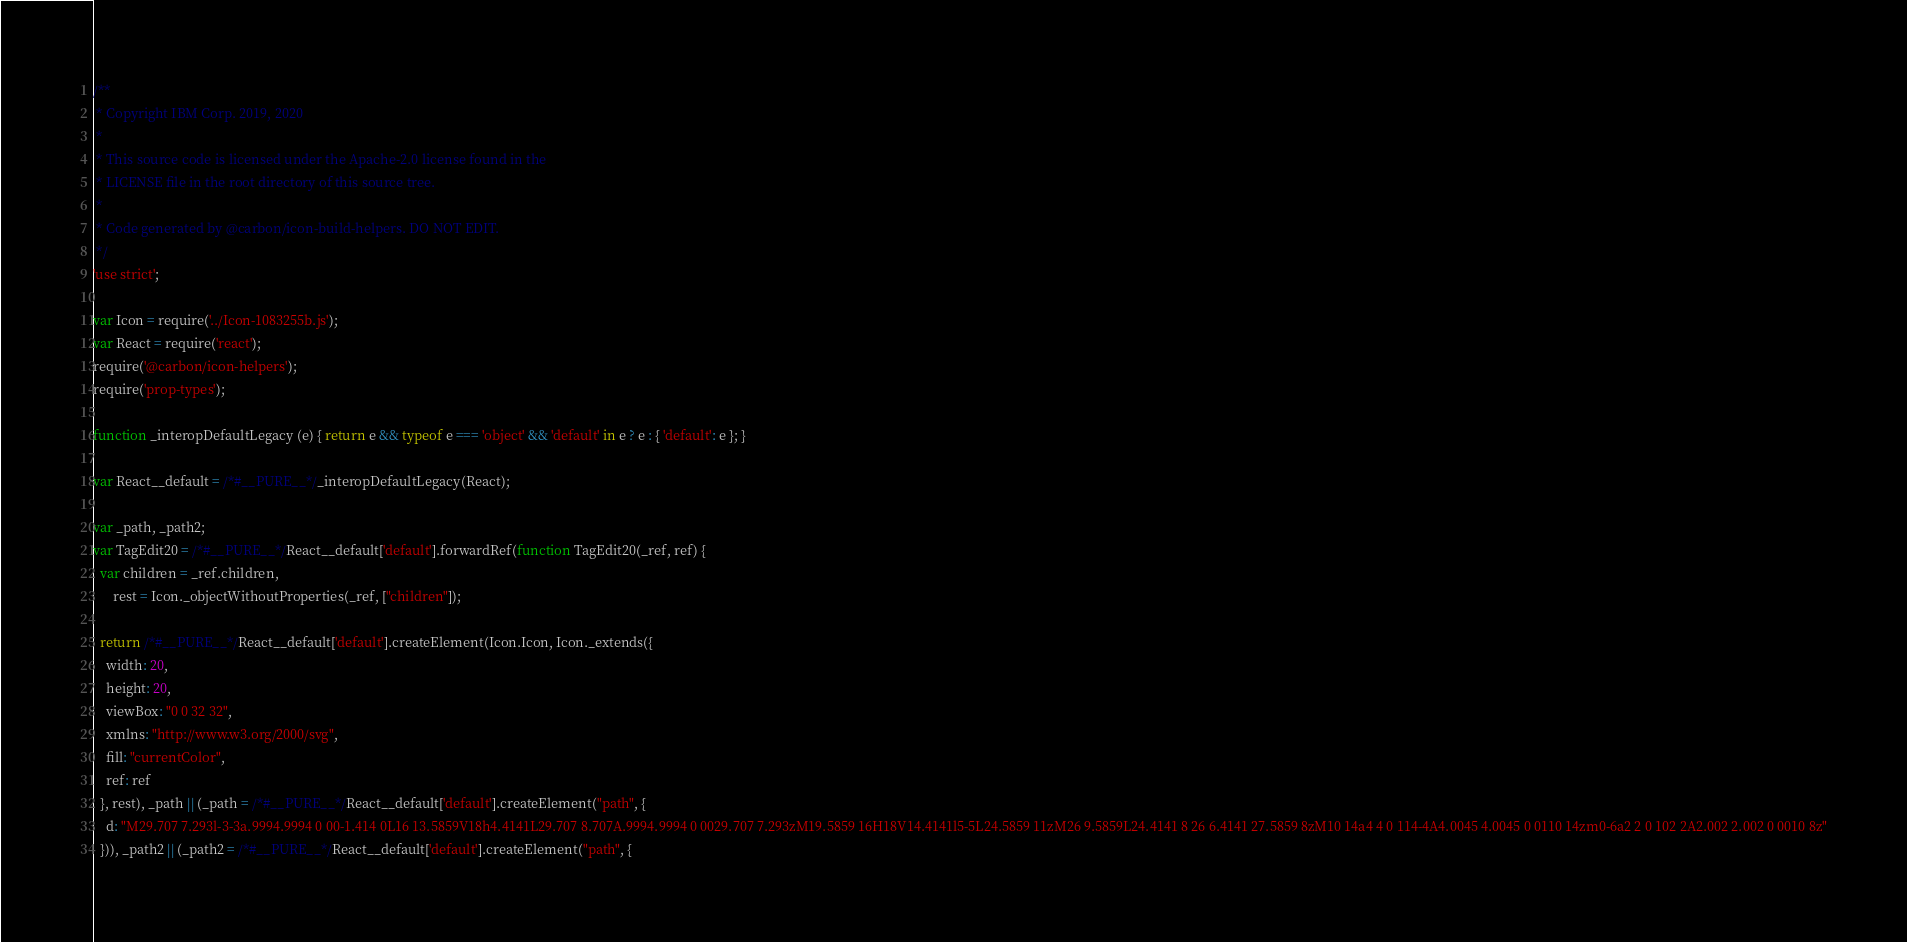Convert code to text. <code><loc_0><loc_0><loc_500><loc_500><_JavaScript_>/**
 * Copyright IBM Corp. 2019, 2020
 *
 * This source code is licensed under the Apache-2.0 license found in the
 * LICENSE file in the root directory of this source tree.
 *
 * Code generated by @carbon/icon-build-helpers. DO NOT EDIT.
 */
'use strict';

var Icon = require('../Icon-1083255b.js');
var React = require('react');
require('@carbon/icon-helpers');
require('prop-types');

function _interopDefaultLegacy (e) { return e && typeof e === 'object' && 'default' in e ? e : { 'default': e }; }

var React__default = /*#__PURE__*/_interopDefaultLegacy(React);

var _path, _path2;
var TagEdit20 = /*#__PURE__*/React__default['default'].forwardRef(function TagEdit20(_ref, ref) {
  var children = _ref.children,
      rest = Icon._objectWithoutProperties(_ref, ["children"]);

  return /*#__PURE__*/React__default['default'].createElement(Icon.Icon, Icon._extends({
    width: 20,
    height: 20,
    viewBox: "0 0 32 32",
    xmlns: "http://www.w3.org/2000/svg",
    fill: "currentColor",
    ref: ref
  }, rest), _path || (_path = /*#__PURE__*/React__default['default'].createElement("path", {
    d: "M29.707 7.293l-3-3a.9994.9994 0 00-1.414 0L16 13.5859V18h4.4141L29.707 8.707A.9994.9994 0 0029.707 7.293zM19.5859 16H18V14.4141l5-5L24.5859 11zM26 9.5859L24.4141 8 26 6.4141 27.5859 8zM10 14a4 4 0 114-4A4.0045 4.0045 0 0110 14zm0-6a2 2 0 102 2A2.002 2.002 0 0010 8z"
  })), _path2 || (_path2 = /*#__PURE__*/React__default['default'].createElement("path", {</code> 